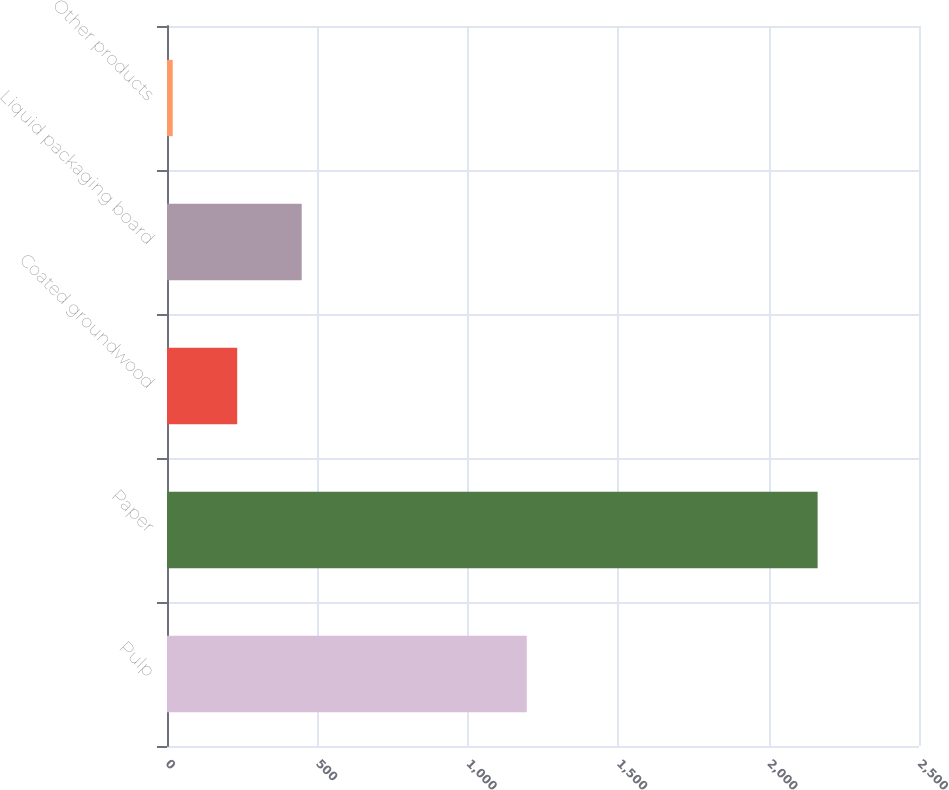<chart> <loc_0><loc_0><loc_500><loc_500><bar_chart><fcel>Pulp<fcel>Paper<fcel>Coated groundwood<fcel>Liquid packaging board<fcel>Other products<nl><fcel>1196<fcel>2163<fcel>233.4<fcel>447.8<fcel>19<nl></chart> 